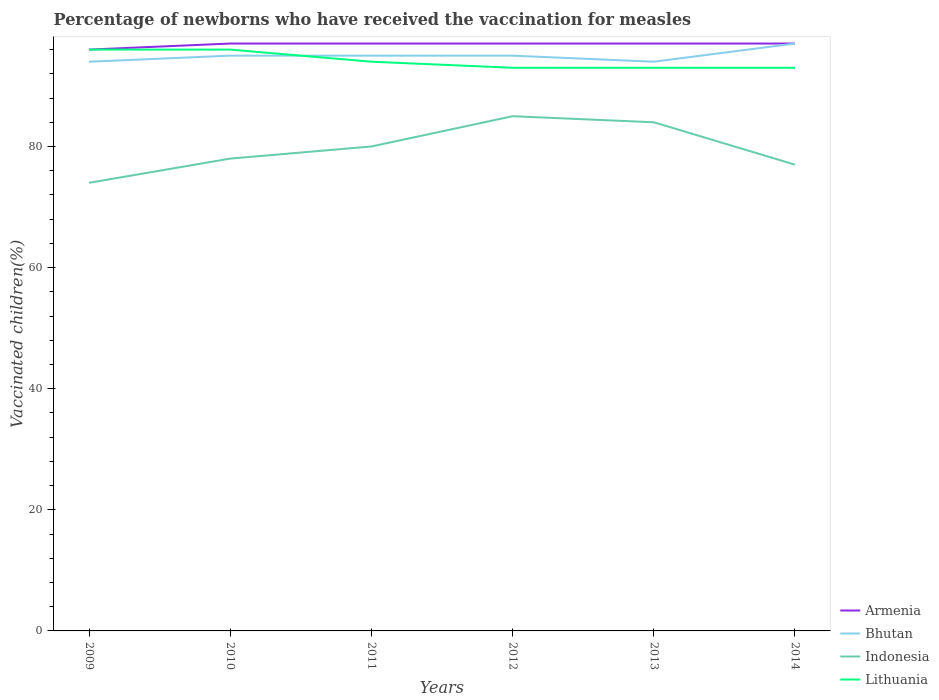Does the line corresponding to Lithuania intersect with the line corresponding to Indonesia?
Your answer should be compact. No. Is the number of lines equal to the number of legend labels?
Keep it short and to the point. Yes. Across all years, what is the maximum percentage of vaccinated children in Bhutan?
Offer a terse response. 94. What is the total percentage of vaccinated children in Armenia in the graph?
Make the answer very short. -1. Is the percentage of vaccinated children in Armenia strictly greater than the percentage of vaccinated children in Lithuania over the years?
Your response must be concise. No. How many years are there in the graph?
Your answer should be compact. 6. Are the values on the major ticks of Y-axis written in scientific E-notation?
Make the answer very short. No. Does the graph contain any zero values?
Offer a very short reply. No. What is the title of the graph?
Your answer should be compact. Percentage of newborns who have received the vaccination for measles. Does "Bahamas" appear as one of the legend labels in the graph?
Provide a succinct answer. No. What is the label or title of the Y-axis?
Provide a short and direct response. Vaccinated children(%). What is the Vaccinated children(%) of Armenia in 2009?
Make the answer very short. 96. What is the Vaccinated children(%) of Bhutan in 2009?
Offer a terse response. 94. What is the Vaccinated children(%) of Indonesia in 2009?
Give a very brief answer. 74. What is the Vaccinated children(%) in Lithuania in 2009?
Offer a very short reply. 96. What is the Vaccinated children(%) of Armenia in 2010?
Provide a short and direct response. 97. What is the Vaccinated children(%) in Indonesia in 2010?
Make the answer very short. 78. What is the Vaccinated children(%) in Lithuania in 2010?
Make the answer very short. 96. What is the Vaccinated children(%) of Armenia in 2011?
Ensure brevity in your answer.  97. What is the Vaccinated children(%) of Bhutan in 2011?
Give a very brief answer. 95. What is the Vaccinated children(%) of Indonesia in 2011?
Keep it short and to the point. 80. What is the Vaccinated children(%) of Lithuania in 2011?
Provide a short and direct response. 94. What is the Vaccinated children(%) of Armenia in 2012?
Provide a short and direct response. 97. What is the Vaccinated children(%) in Indonesia in 2012?
Your answer should be very brief. 85. What is the Vaccinated children(%) in Lithuania in 2012?
Offer a very short reply. 93. What is the Vaccinated children(%) of Armenia in 2013?
Offer a very short reply. 97. What is the Vaccinated children(%) in Bhutan in 2013?
Your answer should be compact. 94. What is the Vaccinated children(%) of Lithuania in 2013?
Your response must be concise. 93. What is the Vaccinated children(%) in Armenia in 2014?
Keep it short and to the point. 97. What is the Vaccinated children(%) of Bhutan in 2014?
Your answer should be very brief. 97. What is the Vaccinated children(%) of Lithuania in 2014?
Your answer should be very brief. 93. Across all years, what is the maximum Vaccinated children(%) of Armenia?
Make the answer very short. 97. Across all years, what is the maximum Vaccinated children(%) in Bhutan?
Your response must be concise. 97. Across all years, what is the maximum Vaccinated children(%) in Lithuania?
Your answer should be compact. 96. Across all years, what is the minimum Vaccinated children(%) in Armenia?
Provide a succinct answer. 96. Across all years, what is the minimum Vaccinated children(%) of Bhutan?
Provide a succinct answer. 94. Across all years, what is the minimum Vaccinated children(%) of Lithuania?
Give a very brief answer. 93. What is the total Vaccinated children(%) of Armenia in the graph?
Give a very brief answer. 581. What is the total Vaccinated children(%) of Bhutan in the graph?
Provide a succinct answer. 570. What is the total Vaccinated children(%) in Indonesia in the graph?
Offer a terse response. 478. What is the total Vaccinated children(%) in Lithuania in the graph?
Provide a short and direct response. 565. What is the difference between the Vaccinated children(%) of Armenia in 2009 and that in 2010?
Keep it short and to the point. -1. What is the difference between the Vaccinated children(%) in Indonesia in 2009 and that in 2010?
Ensure brevity in your answer.  -4. What is the difference between the Vaccinated children(%) of Armenia in 2009 and that in 2011?
Make the answer very short. -1. What is the difference between the Vaccinated children(%) in Bhutan in 2009 and that in 2011?
Ensure brevity in your answer.  -1. What is the difference between the Vaccinated children(%) in Indonesia in 2009 and that in 2011?
Keep it short and to the point. -6. What is the difference between the Vaccinated children(%) of Armenia in 2009 and that in 2012?
Offer a very short reply. -1. What is the difference between the Vaccinated children(%) of Indonesia in 2009 and that in 2012?
Provide a succinct answer. -11. What is the difference between the Vaccinated children(%) in Lithuania in 2009 and that in 2012?
Your response must be concise. 3. What is the difference between the Vaccinated children(%) of Armenia in 2009 and that in 2013?
Keep it short and to the point. -1. What is the difference between the Vaccinated children(%) in Bhutan in 2009 and that in 2013?
Provide a succinct answer. 0. What is the difference between the Vaccinated children(%) of Indonesia in 2009 and that in 2013?
Offer a terse response. -10. What is the difference between the Vaccinated children(%) in Lithuania in 2009 and that in 2013?
Keep it short and to the point. 3. What is the difference between the Vaccinated children(%) in Bhutan in 2009 and that in 2014?
Offer a very short reply. -3. What is the difference between the Vaccinated children(%) of Lithuania in 2009 and that in 2014?
Give a very brief answer. 3. What is the difference between the Vaccinated children(%) of Bhutan in 2010 and that in 2011?
Your answer should be compact. 0. What is the difference between the Vaccinated children(%) of Armenia in 2010 and that in 2012?
Provide a succinct answer. 0. What is the difference between the Vaccinated children(%) of Lithuania in 2010 and that in 2012?
Your answer should be compact. 3. What is the difference between the Vaccinated children(%) in Armenia in 2010 and that in 2013?
Offer a terse response. 0. What is the difference between the Vaccinated children(%) in Armenia in 2010 and that in 2014?
Your answer should be very brief. 0. What is the difference between the Vaccinated children(%) in Indonesia in 2010 and that in 2014?
Make the answer very short. 1. What is the difference between the Vaccinated children(%) of Armenia in 2011 and that in 2012?
Give a very brief answer. 0. What is the difference between the Vaccinated children(%) of Lithuania in 2011 and that in 2012?
Your response must be concise. 1. What is the difference between the Vaccinated children(%) in Armenia in 2011 and that in 2013?
Offer a terse response. 0. What is the difference between the Vaccinated children(%) in Indonesia in 2011 and that in 2014?
Your answer should be compact. 3. What is the difference between the Vaccinated children(%) in Lithuania in 2011 and that in 2014?
Provide a short and direct response. 1. What is the difference between the Vaccinated children(%) in Lithuania in 2012 and that in 2013?
Offer a very short reply. 0. What is the difference between the Vaccinated children(%) of Bhutan in 2012 and that in 2014?
Keep it short and to the point. -2. What is the difference between the Vaccinated children(%) of Armenia in 2013 and that in 2014?
Give a very brief answer. 0. What is the difference between the Vaccinated children(%) of Bhutan in 2013 and that in 2014?
Your response must be concise. -3. What is the difference between the Vaccinated children(%) in Armenia in 2009 and the Vaccinated children(%) in Bhutan in 2010?
Provide a succinct answer. 1. What is the difference between the Vaccinated children(%) in Armenia in 2009 and the Vaccinated children(%) in Lithuania in 2010?
Provide a short and direct response. 0. What is the difference between the Vaccinated children(%) in Bhutan in 2009 and the Vaccinated children(%) in Lithuania in 2010?
Offer a very short reply. -2. What is the difference between the Vaccinated children(%) of Armenia in 2009 and the Vaccinated children(%) of Bhutan in 2011?
Your answer should be very brief. 1. What is the difference between the Vaccinated children(%) of Armenia in 2009 and the Vaccinated children(%) of Lithuania in 2011?
Ensure brevity in your answer.  2. What is the difference between the Vaccinated children(%) of Indonesia in 2009 and the Vaccinated children(%) of Lithuania in 2011?
Offer a terse response. -20. What is the difference between the Vaccinated children(%) of Armenia in 2009 and the Vaccinated children(%) of Lithuania in 2012?
Offer a terse response. 3. What is the difference between the Vaccinated children(%) in Indonesia in 2009 and the Vaccinated children(%) in Lithuania in 2012?
Ensure brevity in your answer.  -19. What is the difference between the Vaccinated children(%) in Armenia in 2009 and the Vaccinated children(%) in Indonesia in 2013?
Ensure brevity in your answer.  12. What is the difference between the Vaccinated children(%) of Bhutan in 2009 and the Vaccinated children(%) of Lithuania in 2013?
Your answer should be very brief. 1. What is the difference between the Vaccinated children(%) in Indonesia in 2009 and the Vaccinated children(%) in Lithuania in 2013?
Provide a succinct answer. -19. What is the difference between the Vaccinated children(%) of Bhutan in 2009 and the Vaccinated children(%) of Indonesia in 2014?
Your answer should be very brief. 17. What is the difference between the Vaccinated children(%) in Bhutan in 2009 and the Vaccinated children(%) in Lithuania in 2014?
Your response must be concise. 1. What is the difference between the Vaccinated children(%) of Indonesia in 2009 and the Vaccinated children(%) of Lithuania in 2014?
Your answer should be very brief. -19. What is the difference between the Vaccinated children(%) in Armenia in 2010 and the Vaccinated children(%) in Bhutan in 2011?
Ensure brevity in your answer.  2. What is the difference between the Vaccinated children(%) of Armenia in 2010 and the Vaccinated children(%) of Indonesia in 2011?
Your answer should be very brief. 17. What is the difference between the Vaccinated children(%) in Bhutan in 2010 and the Vaccinated children(%) in Indonesia in 2011?
Your answer should be compact. 15. What is the difference between the Vaccinated children(%) of Armenia in 2010 and the Vaccinated children(%) of Lithuania in 2012?
Offer a terse response. 4. What is the difference between the Vaccinated children(%) of Bhutan in 2010 and the Vaccinated children(%) of Lithuania in 2012?
Give a very brief answer. 2. What is the difference between the Vaccinated children(%) in Indonesia in 2010 and the Vaccinated children(%) in Lithuania in 2012?
Your answer should be very brief. -15. What is the difference between the Vaccinated children(%) of Armenia in 2010 and the Vaccinated children(%) of Bhutan in 2013?
Provide a succinct answer. 3. What is the difference between the Vaccinated children(%) in Armenia in 2010 and the Vaccinated children(%) in Indonesia in 2013?
Your response must be concise. 13. What is the difference between the Vaccinated children(%) in Bhutan in 2010 and the Vaccinated children(%) in Indonesia in 2013?
Your answer should be compact. 11. What is the difference between the Vaccinated children(%) in Bhutan in 2010 and the Vaccinated children(%) in Lithuania in 2013?
Your answer should be very brief. 2. What is the difference between the Vaccinated children(%) in Indonesia in 2010 and the Vaccinated children(%) in Lithuania in 2013?
Ensure brevity in your answer.  -15. What is the difference between the Vaccinated children(%) of Armenia in 2010 and the Vaccinated children(%) of Bhutan in 2014?
Ensure brevity in your answer.  0. What is the difference between the Vaccinated children(%) of Armenia in 2010 and the Vaccinated children(%) of Indonesia in 2014?
Your answer should be compact. 20. What is the difference between the Vaccinated children(%) of Armenia in 2010 and the Vaccinated children(%) of Lithuania in 2014?
Your response must be concise. 4. What is the difference between the Vaccinated children(%) of Indonesia in 2010 and the Vaccinated children(%) of Lithuania in 2014?
Provide a succinct answer. -15. What is the difference between the Vaccinated children(%) of Armenia in 2011 and the Vaccinated children(%) of Bhutan in 2012?
Provide a succinct answer. 2. What is the difference between the Vaccinated children(%) of Armenia in 2011 and the Vaccinated children(%) of Indonesia in 2012?
Your answer should be compact. 12. What is the difference between the Vaccinated children(%) of Bhutan in 2011 and the Vaccinated children(%) of Indonesia in 2012?
Keep it short and to the point. 10. What is the difference between the Vaccinated children(%) of Armenia in 2011 and the Vaccinated children(%) of Bhutan in 2013?
Offer a very short reply. 3. What is the difference between the Vaccinated children(%) in Armenia in 2011 and the Vaccinated children(%) in Lithuania in 2013?
Your response must be concise. 4. What is the difference between the Vaccinated children(%) in Bhutan in 2011 and the Vaccinated children(%) in Indonesia in 2013?
Your answer should be compact. 11. What is the difference between the Vaccinated children(%) in Armenia in 2011 and the Vaccinated children(%) in Bhutan in 2014?
Make the answer very short. 0. What is the difference between the Vaccinated children(%) in Armenia in 2011 and the Vaccinated children(%) in Lithuania in 2014?
Your answer should be compact. 4. What is the difference between the Vaccinated children(%) in Bhutan in 2011 and the Vaccinated children(%) in Indonesia in 2014?
Your answer should be compact. 18. What is the difference between the Vaccinated children(%) in Bhutan in 2011 and the Vaccinated children(%) in Lithuania in 2014?
Provide a succinct answer. 2. What is the difference between the Vaccinated children(%) in Indonesia in 2011 and the Vaccinated children(%) in Lithuania in 2014?
Make the answer very short. -13. What is the difference between the Vaccinated children(%) of Armenia in 2012 and the Vaccinated children(%) of Bhutan in 2013?
Ensure brevity in your answer.  3. What is the difference between the Vaccinated children(%) of Armenia in 2012 and the Vaccinated children(%) of Indonesia in 2013?
Offer a very short reply. 13. What is the difference between the Vaccinated children(%) of Bhutan in 2012 and the Vaccinated children(%) of Indonesia in 2013?
Ensure brevity in your answer.  11. What is the difference between the Vaccinated children(%) of Indonesia in 2012 and the Vaccinated children(%) of Lithuania in 2013?
Make the answer very short. -8. What is the difference between the Vaccinated children(%) in Armenia in 2012 and the Vaccinated children(%) in Bhutan in 2014?
Offer a terse response. 0. What is the difference between the Vaccinated children(%) in Armenia in 2012 and the Vaccinated children(%) in Lithuania in 2014?
Keep it short and to the point. 4. What is the difference between the Vaccinated children(%) of Bhutan in 2012 and the Vaccinated children(%) of Lithuania in 2014?
Give a very brief answer. 2. What is the difference between the Vaccinated children(%) in Indonesia in 2012 and the Vaccinated children(%) in Lithuania in 2014?
Your answer should be very brief. -8. What is the difference between the Vaccinated children(%) of Armenia in 2013 and the Vaccinated children(%) of Bhutan in 2014?
Keep it short and to the point. 0. What is the difference between the Vaccinated children(%) of Bhutan in 2013 and the Vaccinated children(%) of Lithuania in 2014?
Your answer should be very brief. 1. What is the difference between the Vaccinated children(%) in Indonesia in 2013 and the Vaccinated children(%) in Lithuania in 2014?
Ensure brevity in your answer.  -9. What is the average Vaccinated children(%) of Armenia per year?
Your response must be concise. 96.83. What is the average Vaccinated children(%) of Bhutan per year?
Your answer should be compact. 95. What is the average Vaccinated children(%) in Indonesia per year?
Offer a very short reply. 79.67. What is the average Vaccinated children(%) of Lithuania per year?
Your response must be concise. 94.17. In the year 2009, what is the difference between the Vaccinated children(%) in Armenia and Vaccinated children(%) in Bhutan?
Ensure brevity in your answer.  2. In the year 2009, what is the difference between the Vaccinated children(%) in Armenia and Vaccinated children(%) in Indonesia?
Your answer should be very brief. 22. In the year 2009, what is the difference between the Vaccinated children(%) of Armenia and Vaccinated children(%) of Lithuania?
Make the answer very short. 0. In the year 2009, what is the difference between the Vaccinated children(%) in Bhutan and Vaccinated children(%) in Lithuania?
Ensure brevity in your answer.  -2. In the year 2010, what is the difference between the Vaccinated children(%) in Armenia and Vaccinated children(%) in Bhutan?
Provide a short and direct response. 2. In the year 2010, what is the difference between the Vaccinated children(%) in Armenia and Vaccinated children(%) in Indonesia?
Keep it short and to the point. 19. In the year 2010, what is the difference between the Vaccinated children(%) in Bhutan and Vaccinated children(%) in Indonesia?
Ensure brevity in your answer.  17. In the year 2010, what is the difference between the Vaccinated children(%) of Indonesia and Vaccinated children(%) of Lithuania?
Your response must be concise. -18. In the year 2011, what is the difference between the Vaccinated children(%) in Armenia and Vaccinated children(%) in Indonesia?
Keep it short and to the point. 17. In the year 2011, what is the difference between the Vaccinated children(%) of Armenia and Vaccinated children(%) of Lithuania?
Your answer should be compact. 3. In the year 2011, what is the difference between the Vaccinated children(%) of Indonesia and Vaccinated children(%) of Lithuania?
Offer a very short reply. -14. In the year 2012, what is the difference between the Vaccinated children(%) of Armenia and Vaccinated children(%) of Lithuania?
Offer a very short reply. 4. In the year 2012, what is the difference between the Vaccinated children(%) in Bhutan and Vaccinated children(%) in Indonesia?
Ensure brevity in your answer.  10. In the year 2012, what is the difference between the Vaccinated children(%) of Bhutan and Vaccinated children(%) of Lithuania?
Your answer should be very brief. 2. In the year 2013, what is the difference between the Vaccinated children(%) of Armenia and Vaccinated children(%) of Bhutan?
Keep it short and to the point. 3. In the year 2013, what is the difference between the Vaccinated children(%) in Bhutan and Vaccinated children(%) in Indonesia?
Ensure brevity in your answer.  10. In the year 2013, what is the difference between the Vaccinated children(%) of Bhutan and Vaccinated children(%) of Lithuania?
Offer a very short reply. 1. In the year 2014, what is the difference between the Vaccinated children(%) of Armenia and Vaccinated children(%) of Lithuania?
Provide a short and direct response. 4. In the year 2014, what is the difference between the Vaccinated children(%) of Bhutan and Vaccinated children(%) of Indonesia?
Offer a very short reply. 20. In the year 2014, what is the difference between the Vaccinated children(%) of Indonesia and Vaccinated children(%) of Lithuania?
Your answer should be very brief. -16. What is the ratio of the Vaccinated children(%) in Indonesia in 2009 to that in 2010?
Provide a short and direct response. 0.95. What is the ratio of the Vaccinated children(%) of Lithuania in 2009 to that in 2010?
Offer a terse response. 1. What is the ratio of the Vaccinated children(%) of Bhutan in 2009 to that in 2011?
Provide a short and direct response. 0.99. What is the ratio of the Vaccinated children(%) in Indonesia in 2009 to that in 2011?
Your response must be concise. 0.93. What is the ratio of the Vaccinated children(%) of Lithuania in 2009 to that in 2011?
Provide a short and direct response. 1.02. What is the ratio of the Vaccinated children(%) of Indonesia in 2009 to that in 2012?
Offer a terse response. 0.87. What is the ratio of the Vaccinated children(%) of Lithuania in 2009 to that in 2012?
Offer a terse response. 1.03. What is the ratio of the Vaccinated children(%) in Bhutan in 2009 to that in 2013?
Provide a succinct answer. 1. What is the ratio of the Vaccinated children(%) of Indonesia in 2009 to that in 2013?
Give a very brief answer. 0.88. What is the ratio of the Vaccinated children(%) in Lithuania in 2009 to that in 2013?
Offer a terse response. 1.03. What is the ratio of the Vaccinated children(%) of Bhutan in 2009 to that in 2014?
Give a very brief answer. 0.97. What is the ratio of the Vaccinated children(%) of Indonesia in 2009 to that in 2014?
Your answer should be compact. 0.96. What is the ratio of the Vaccinated children(%) of Lithuania in 2009 to that in 2014?
Provide a short and direct response. 1.03. What is the ratio of the Vaccinated children(%) of Armenia in 2010 to that in 2011?
Offer a very short reply. 1. What is the ratio of the Vaccinated children(%) in Bhutan in 2010 to that in 2011?
Your response must be concise. 1. What is the ratio of the Vaccinated children(%) of Indonesia in 2010 to that in 2011?
Offer a very short reply. 0.97. What is the ratio of the Vaccinated children(%) of Lithuania in 2010 to that in 2011?
Ensure brevity in your answer.  1.02. What is the ratio of the Vaccinated children(%) in Indonesia in 2010 to that in 2012?
Offer a very short reply. 0.92. What is the ratio of the Vaccinated children(%) in Lithuania in 2010 to that in 2012?
Provide a short and direct response. 1.03. What is the ratio of the Vaccinated children(%) in Armenia in 2010 to that in 2013?
Offer a very short reply. 1. What is the ratio of the Vaccinated children(%) of Bhutan in 2010 to that in 2013?
Make the answer very short. 1.01. What is the ratio of the Vaccinated children(%) of Lithuania in 2010 to that in 2013?
Provide a short and direct response. 1.03. What is the ratio of the Vaccinated children(%) of Bhutan in 2010 to that in 2014?
Keep it short and to the point. 0.98. What is the ratio of the Vaccinated children(%) of Lithuania in 2010 to that in 2014?
Make the answer very short. 1.03. What is the ratio of the Vaccinated children(%) in Armenia in 2011 to that in 2012?
Provide a short and direct response. 1. What is the ratio of the Vaccinated children(%) in Bhutan in 2011 to that in 2012?
Ensure brevity in your answer.  1. What is the ratio of the Vaccinated children(%) in Lithuania in 2011 to that in 2012?
Offer a terse response. 1.01. What is the ratio of the Vaccinated children(%) in Bhutan in 2011 to that in 2013?
Offer a terse response. 1.01. What is the ratio of the Vaccinated children(%) in Lithuania in 2011 to that in 2013?
Your answer should be compact. 1.01. What is the ratio of the Vaccinated children(%) in Armenia in 2011 to that in 2014?
Provide a succinct answer. 1. What is the ratio of the Vaccinated children(%) in Bhutan in 2011 to that in 2014?
Ensure brevity in your answer.  0.98. What is the ratio of the Vaccinated children(%) of Indonesia in 2011 to that in 2014?
Your answer should be compact. 1.04. What is the ratio of the Vaccinated children(%) in Lithuania in 2011 to that in 2014?
Offer a terse response. 1.01. What is the ratio of the Vaccinated children(%) in Armenia in 2012 to that in 2013?
Ensure brevity in your answer.  1. What is the ratio of the Vaccinated children(%) of Bhutan in 2012 to that in 2013?
Keep it short and to the point. 1.01. What is the ratio of the Vaccinated children(%) in Indonesia in 2012 to that in 2013?
Keep it short and to the point. 1.01. What is the ratio of the Vaccinated children(%) of Bhutan in 2012 to that in 2014?
Provide a succinct answer. 0.98. What is the ratio of the Vaccinated children(%) of Indonesia in 2012 to that in 2014?
Give a very brief answer. 1.1. What is the ratio of the Vaccinated children(%) of Lithuania in 2012 to that in 2014?
Your answer should be very brief. 1. What is the ratio of the Vaccinated children(%) of Armenia in 2013 to that in 2014?
Give a very brief answer. 1. What is the ratio of the Vaccinated children(%) in Bhutan in 2013 to that in 2014?
Your answer should be very brief. 0.97. What is the ratio of the Vaccinated children(%) of Indonesia in 2013 to that in 2014?
Provide a short and direct response. 1.09. What is the ratio of the Vaccinated children(%) of Lithuania in 2013 to that in 2014?
Ensure brevity in your answer.  1. What is the difference between the highest and the second highest Vaccinated children(%) in Bhutan?
Keep it short and to the point. 2. What is the difference between the highest and the second highest Vaccinated children(%) in Lithuania?
Make the answer very short. 0. What is the difference between the highest and the lowest Vaccinated children(%) in Armenia?
Your response must be concise. 1. What is the difference between the highest and the lowest Vaccinated children(%) of Indonesia?
Provide a short and direct response. 11. What is the difference between the highest and the lowest Vaccinated children(%) in Lithuania?
Your answer should be very brief. 3. 